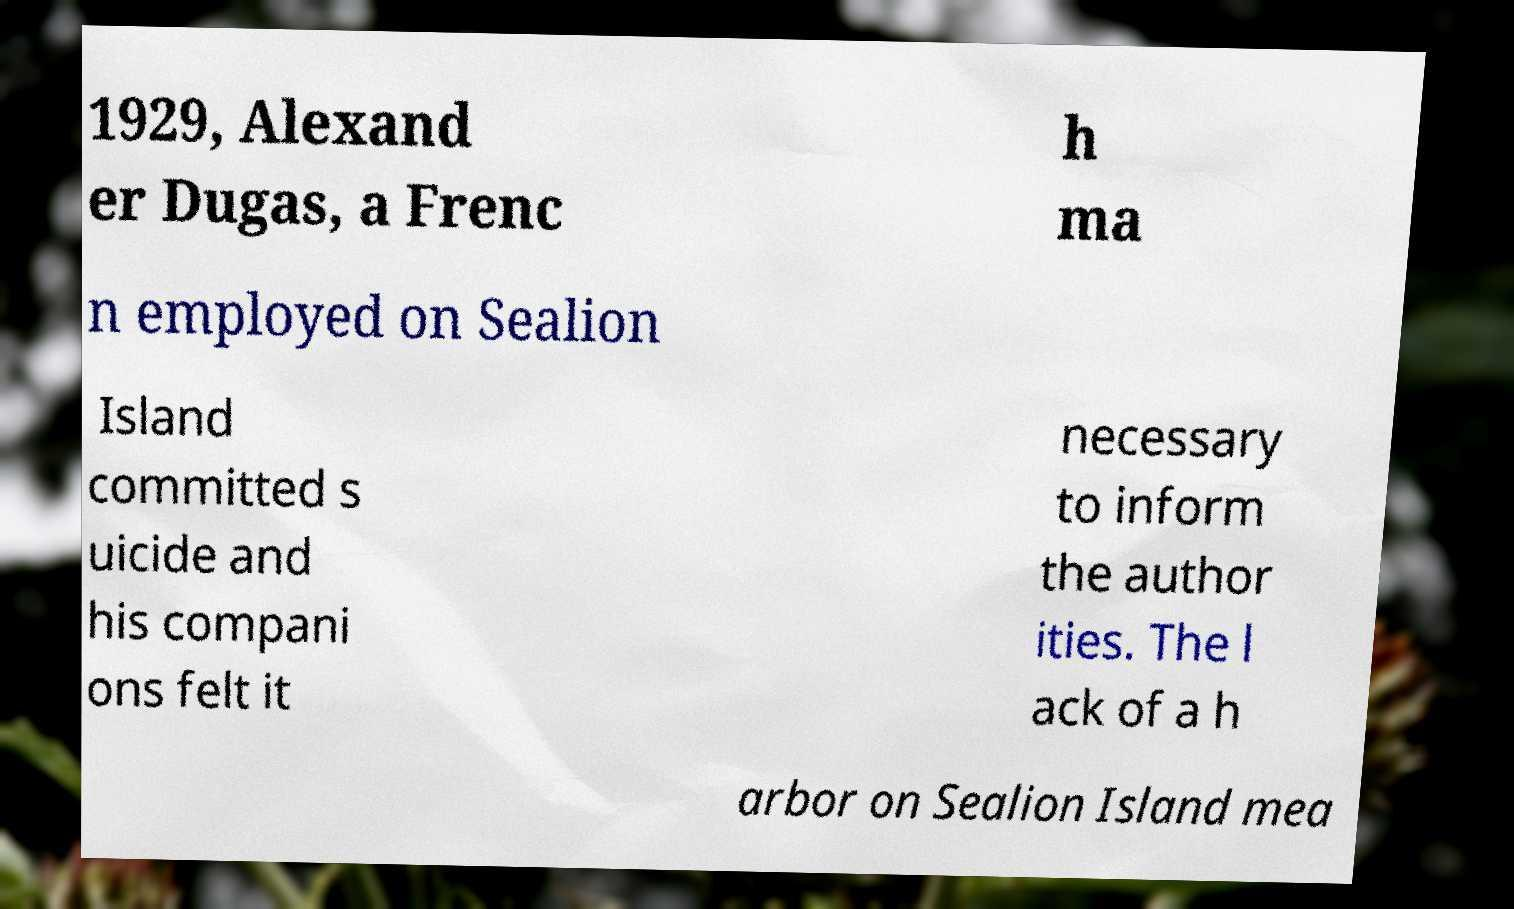What messages or text are displayed in this image? I need them in a readable, typed format. 1929, Alexand er Dugas, a Frenc h ma n employed on Sealion Island committed s uicide and his compani ons felt it necessary to inform the author ities. The l ack of a h arbor on Sealion Island mea 